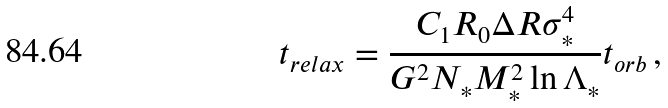Convert formula to latex. <formula><loc_0><loc_0><loc_500><loc_500>t _ { r e l a x } = \frac { C _ { 1 } R _ { 0 } \Delta R \sigma _ { * } ^ { 4 } } { G ^ { 2 } N _ { * } M _ { * } ^ { 2 } \ln \Lambda _ { * } } t _ { o r b } \, ,</formula> 